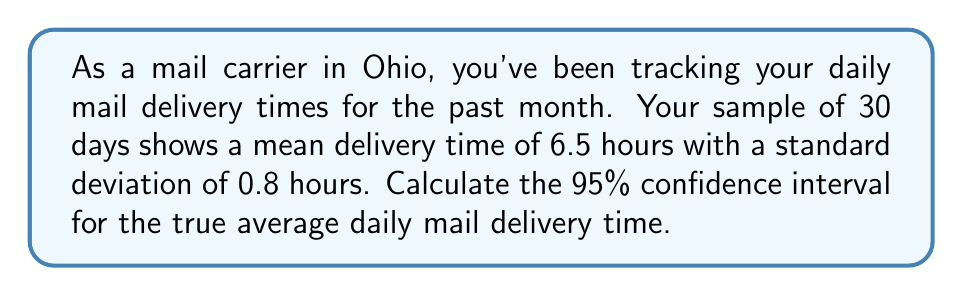Provide a solution to this math problem. To calculate the 95% confidence interval, we'll follow these steps:

1) The formula for the confidence interval is:

   $$\bar{x} \pm t_{\alpha/2} \cdot \frac{s}{\sqrt{n}}$$

   Where:
   $\bar{x}$ is the sample mean
   $t_{\alpha/2}$ is the t-value for 95% confidence level with n-1 degrees of freedom
   $s$ is the sample standard deviation
   $n$ is the sample size

2) We know:
   $\bar{x} = 6.5$ hours
   $s = 0.8$ hours
   $n = 30$
   Confidence level = 95%

3) For a 95% confidence level with 29 degrees of freedom (n-1), the t-value is approximately 2.045.

4) Plugging these values into the formula:

   $$6.5 \pm 2.045 \cdot \frac{0.8}{\sqrt{30}}$$

5) Simplify:
   $$6.5 \pm 2.045 \cdot \frac{0.8}{5.477}$$
   $$6.5 \pm 2.045 \cdot 0.146$$
   $$6.5 \pm 0.299$$

6) Therefore, the confidence interval is:
   $$(6.5 - 0.299, 6.5 + 0.299)$$
   $$(6.201, 6.799)$$
Answer: (6.201, 6.799) hours 